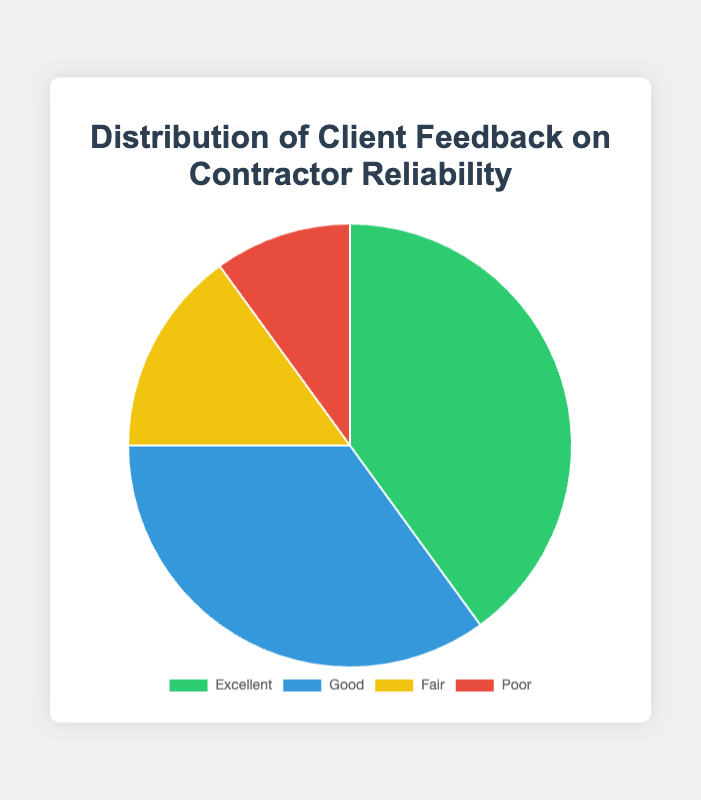what percentage of client feedback is categorized as "Poor"? Look at the section labeled "Poor" in the pie chart. It’s represented as a slice of the pie. The chart will show 10%.
Answer: 10% which feedback category is the largest? By examining the slices of the pie chart, we can see that the "Excellent" category takes up the largest portion of the chart.
Answer: Excellent what is the combined percentage of "Good" and "Fair" feedback? Add the slices of the pie chart representing "Good" (35%) and "Fair" (15%). So, 35% + 15% = 50%.
Answer: 50% how much larger is the "Excellent" category compared to the "Fair" category? Subtract the "Fair" percentage from the "Excellent" percentage. The "Excellent" category is 40% and the "Fair" category is 15%, so 40% - 15% = 25%.
Answer: 25% is the sum of "Excellent" and "Good" feedback greater than 50%? Add the percentages of the "Excellent" and "Good" categories. "Excellent" is 40% and "Good" is 35%, so 40% + 35% = 75%, which is greater than 50%.
Answer: Yes what is the total percentage of feedback that is neither "Excellent" nor "Poor"? Add the percentages of the "Good" and "Fair" categories. "Good" is 35% and "Fair" is 15%, so 35% + 15% = 50%.
Answer: 50% which feedback category is represented by the blue color? Refer to the legend or the slices of the pie chart. The "Good" feedback category is shown in blue.
Answer: Good 